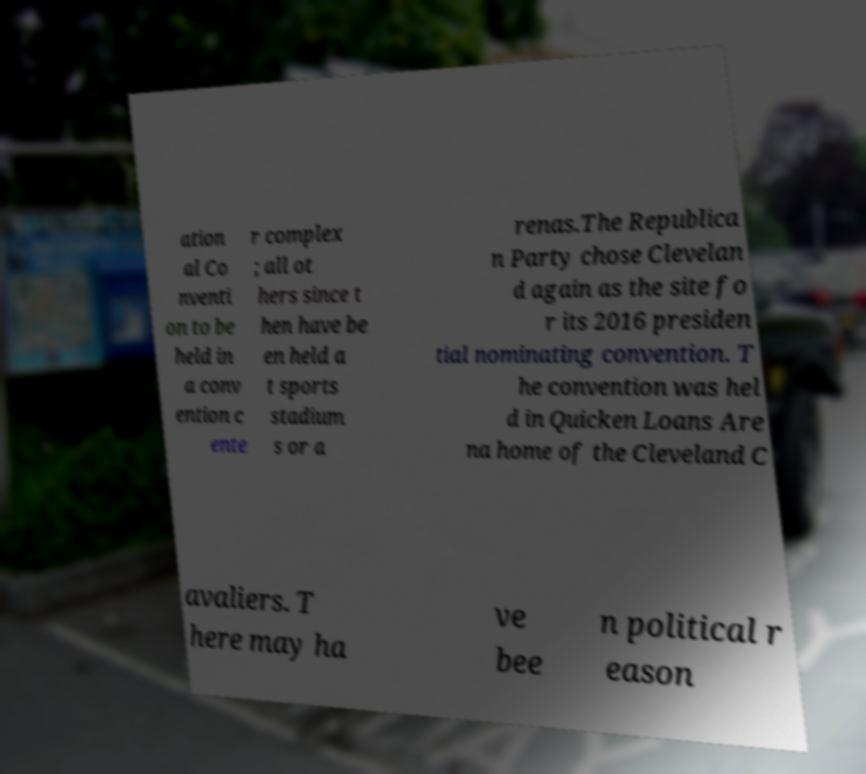Could you assist in decoding the text presented in this image and type it out clearly? ation al Co nventi on to be held in a conv ention c ente r complex ; all ot hers since t hen have be en held a t sports stadium s or a renas.The Republica n Party chose Clevelan d again as the site fo r its 2016 presiden tial nominating convention. T he convention was hel d in Quicken Loans Are na home of the Cleveland C avaliers. T here may ha ve bee n political r eason 